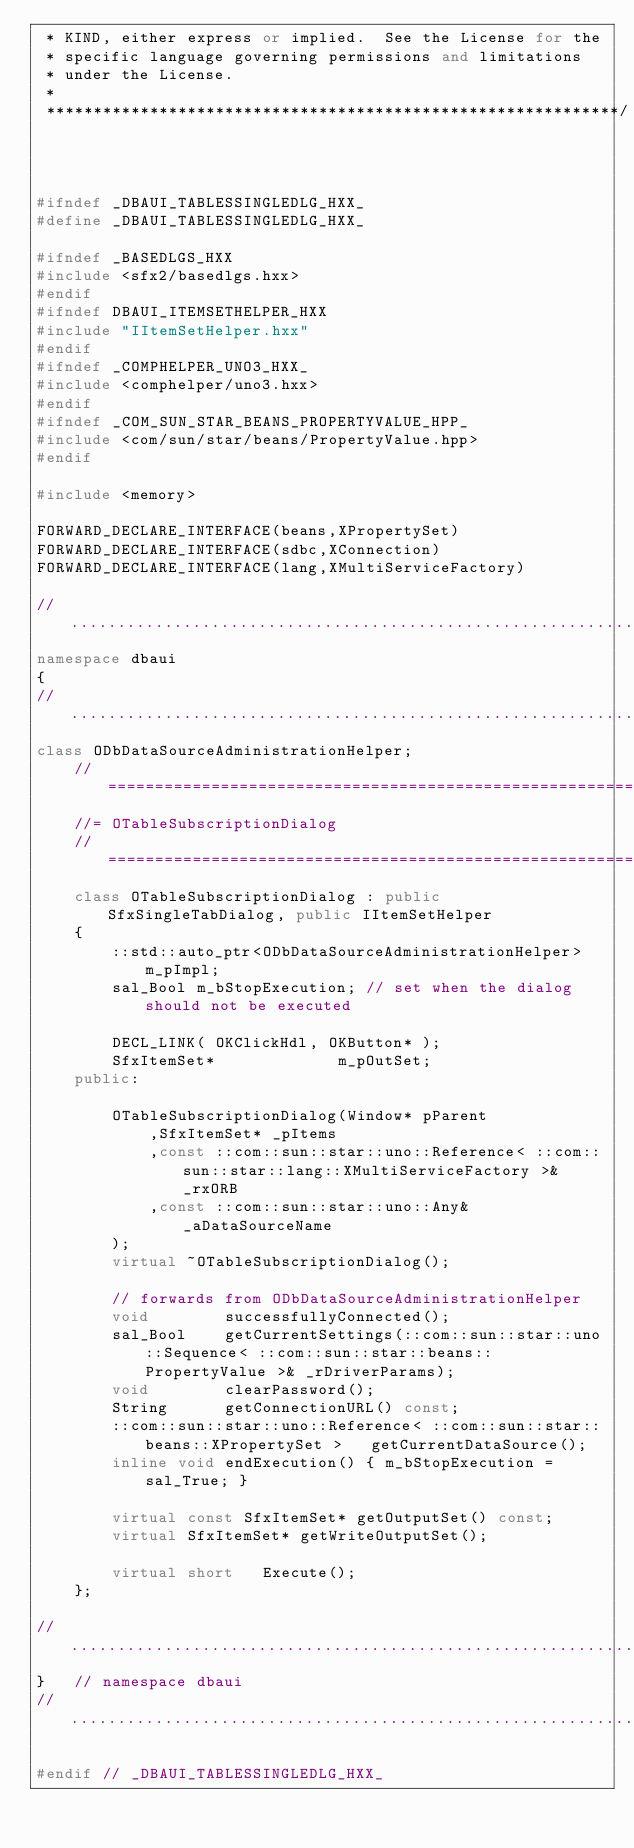<code> <loc_0><loc_0><loc_500><loc_500><_C++_> * KIND, either express or implied.  See the License for the
 * specific language governing permissions and limitations
 * under the License.
 * 
 *************************************************************/



#ifndef _DBAUI_TABLESSINGLEDLG_HXX_
#define _DBAUI_TABLESSINGLEDLG_HXX_

#ifndef _BASEDLGS_HXX
#include <sfx2/basedlgs.hxx>
#endif
#ifndef DBAUI_ITEMSETHELPER_HXX
#include "IItemSetHelper.hxx"
#endif
#ifndef _COMPHELPER_UNO3_HXX_
#include <comphelper/uno3.hxx>
#endif
#ifndef _COM_SUN_STAR_BEANS_PROPERTYVALUE_HPP_
#include <com/sun/star/beans/PropertyValue.hpp>
#endif

#include <memory>

FORWARD_DECLARE_INTERFACE(beans,XPropertySet)
FORWARD_DECLARE_INTERFACE(sdbc,XConnection)
FORWARD_DECLARE_INTERFACE(lang,XMultiServiceFactory)

//.........................................................................
namespace dbaui
{
//.........................................................................
class ODbDataSourceAdministrationHelper;
	//========================================================================
	//= OTableSubscriptionDialog
	//========================================================================
	class OTableSubscriptionDialog : public SfxSingleTabDialog, public IItemSetHelper
	{
		::std::auto_ptr<ODbDataSourceAdministrationHelper>	m_pImpl;
		sal_Bool m_bStopExecution; // set when the dialog should not be executed

		DECL_LINK( OKClickHdl, OKButton* );
		SfxItemSet*				m_pOutSet;
	public:

		OTableSubscriptionDialog(Window* pParent
			,SfxItemSet* _pItems
			,const ::com::sun::star::uno::Reference< ::com::sun::star::lang::XMultiServiceFactory >& _rxORB
			,const ::com::sun::star::uno::Any& _aDataSourceName
		);
		virtual ~OTableSubscriptionDialog();

		// forwards from ODbDataSourceAdministrationHelper
		void		successfullyConnected();
		sal_Bool	getCurrentSettings(::com::sun::star::uno::Sequence< ::com::sun::star::beans::PropertyValue >& _rDriverParams);
		void		clearPassword();
		String		getConnectionURL() const;
		::com::sun::star::uno::Reference< ::com::sun::star::beans::XPropertySet >	getCurrentDataSource();
		inline void endExecution() { m_bStopExecution = sal_True; }

		virtual const SfxItemSet* getOutputSet() const;
		virtual SfxItemSet* getWriteOutputSet();

		virtual short	Execute();
	};

//.........................................................................
}	// namespace dbaui
//.........................................................................

#endif // _DBAUI_TABLESSINGLEDLG_HXX_

</code> 